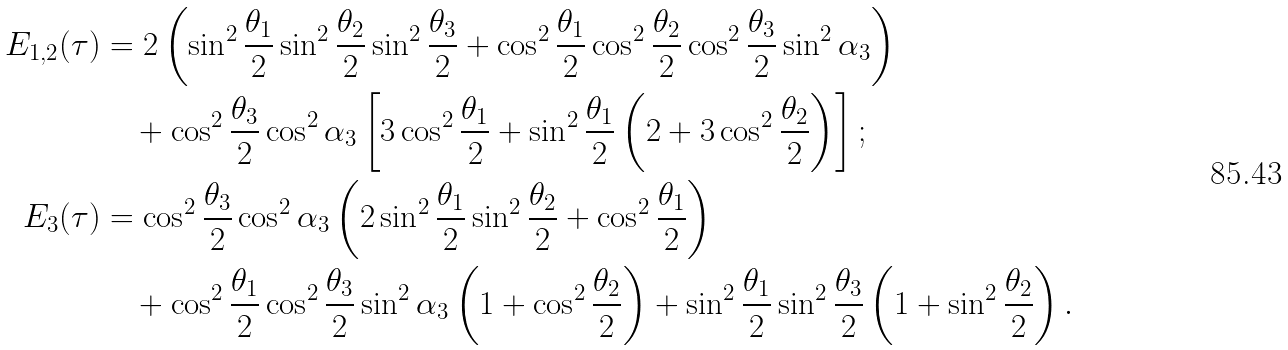Convert formula to latex. <formula><loc_0><loc_0><loc_500><loc_500>E _ { 1 , 2 } ( \tau ) & = 2 \left ( \sin ^ { 2 } \frac { \theta _ { 1 } } { 2 } \sin ^ { 2 } \frac { \theta _ { 2 } } { 2 } \sin ^ { 2 } \frac { \theta _ { 3 } } { 2 } + \cos ^ { 2 } \frac { \theta _ { 1 } } { 2 } \cos ^ { 2 } \frac { \theta _ { 2 } } { 2 } \cos ^ { 2 } \frac { \theta _ { 3 } } { 2 } \sin ^ { 2 } \alpha _ { 3 } \right ) \\ & \quad + \cos ^ { 2 } \frac { \theta _ { 3 } } { 2 } \cos ^ { 2 } \alpha _ { 3 } \left [ 3 \cos ^ { 2 } \frac { \theta _ { 1 } } { 2 } + \sin ^ { 2 } \frac { \theta _ { 1 } } { 2 } \left ( 2 + 3 \cos ^ { 2 } \frac { \theta _ { 2 } } { 2 } \right ) \right ] ; \\ E _ { 3 } ( \tau ) & = \cos ^ { 2 } \frac { \theta _ { 3 } } { 2 } \cos ^ { 2 } \alpha _ { 3 } \left ( 2 \sin ^ { 2 } \frac { \theta _ { 1 } } { 2 } \sin ^ { 2 } \frac { \theta _ { 2 } } { 2 } + \cos ^ { 2 } \frac { \theta _ { 1 } } { 2 } \right ) \\ & \quad + \cos ^ { 2 } { \frac { \theta _ { 1 } } { 2 } } \cos ^ { 2 } \frac { \theta _ { 3 } } { 2 } \sin ^ { 2 } { \alpha _ { 3 } } \left ( 1 + \cos ^ { 2 } \frac { \theta _ { 2 } } { 2 } \right ) + \sin ^ { 2 } \frac { \theta _ { 1 } } { 2 } \sin ^ { 2 } \frac { \theta _ { 3 } } { 2 } \left ( 1 + \sin ^ { 2 } \frac { \theta _ { 2 } } { 2 } \right ) .</formula> 